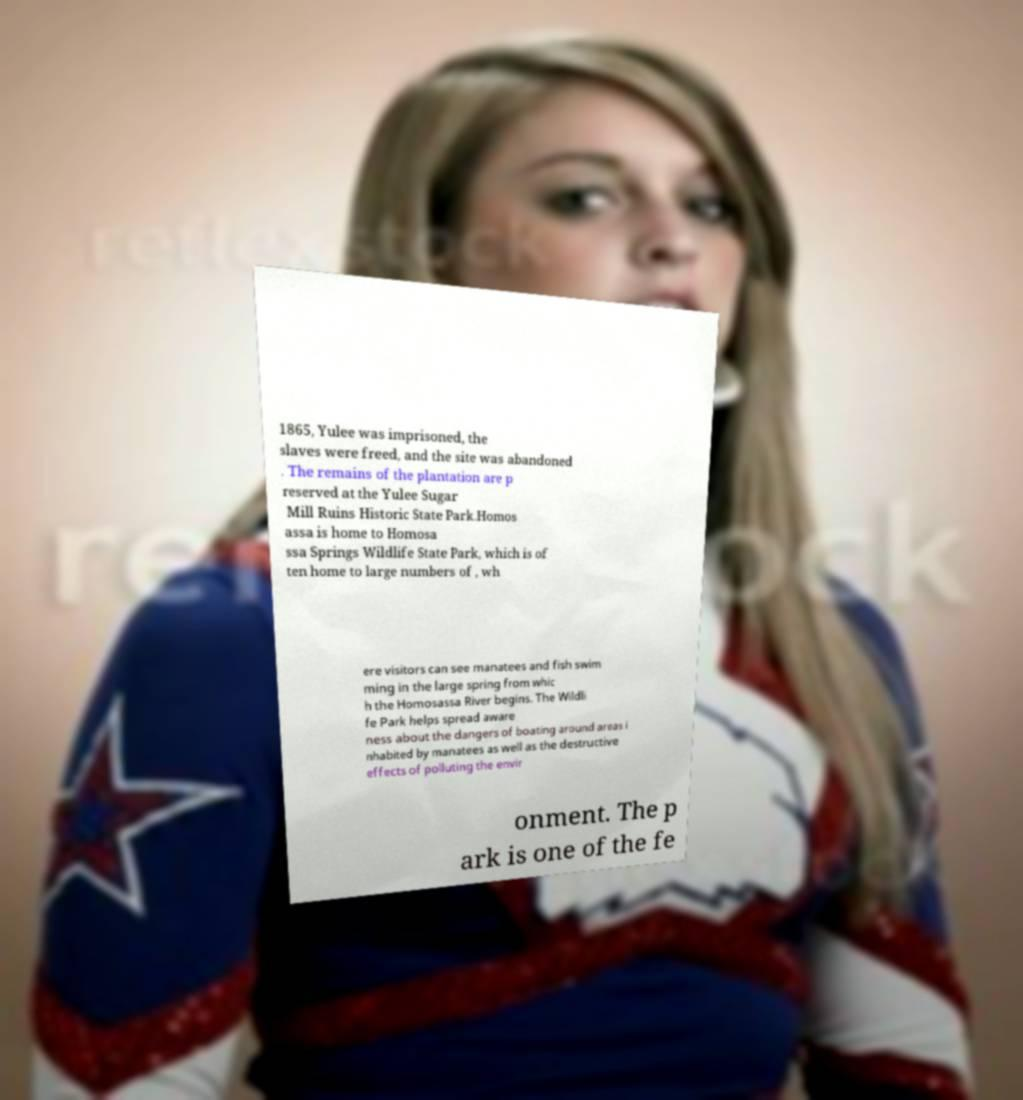Can you accurately transcribe the text from the provided image for me? 1865, Yulee was imprisoned, the slaves were freed, and the site was abandoned . The remains of the plantation are p reserved at the Yulee Sugar Mill Ruins Historic State Park.Homos assa is home to Homosa ssa Springs Wildlife State Park, which is of ten home to large numbers of , wh ere visitors can see manatees and fish swim ming in the large spring from whic h the Homosassa River begins. The Wildli fe Park helps spread aware ness about the dangers of boating around areas i nhabited by manatees as well as the destructive effects of polluting the envir onment. The p ark is one of the fe 